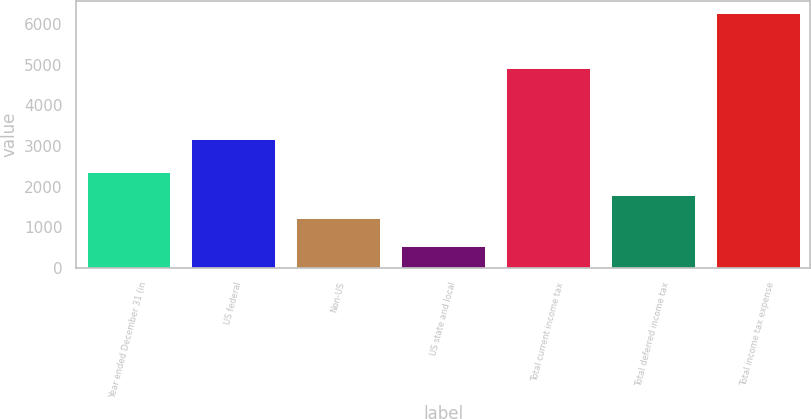Convert chart to OTSL. <chart><loc_0><loc_0><loc_500><loc_500><bar_chart><fcel>Year ended December 31 (in<fcel>US federal<fcel>Non-US<fcel>US state and local<fcel>Total current income tax<fcel>Total deferred income tax<fcel>Total income tax expense<nl><fcel>2362.6<fcel>3160<fcel>1220<fcel>547<fcel>4927<fcel>1791.3<fcel>6260<nl></chart> 